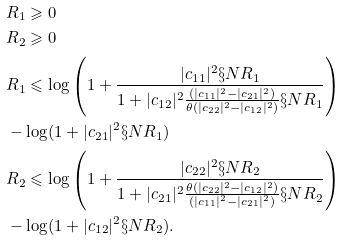Convert formula to latex. <formula><loc_0><loc_0><loc_500><loc_500>& R _ { 1 } \geqslant 0 \\ & R _ { 2 } \geqslant 0 \\ & R _ { 1 } \leqslant \log \left ( 1 + \frac { | c _ { 1 1 } | ^ { 2 } \S N R _ { 1 } } { 1 + | c _ { 1 2 } | ^ { 2 } \frac { ( | c _ { 1 1 } | ^ { 2 } - | c _ { 2 1 } | ^ { 2 } ) } { \theta ( | c _ { 2 2 } | ^ { 2 } - | c _ { 1 2 } | ^ { 2 } ) } \S N R _ { 1 } } \right ) \\ & - \log ( 1 + | c _ { 2 1 } | ^ { 2 } \S N R _ { 1 } ) \\ & R _ { 2 } \leqslant \log \left ( 1 + \frac { | c _ { 2 2 } | ^ { 2 } \S N R _ { 2 } } { 1 + | c _ { 2 1 } | ^ { 2 } \frac { \theta ( | c _ { 2 2 } | ^ { 2 } - | c _ { 1 2 } | ^ { 2 } ) } { ( | c _ { 1 1 } | ^ { 2 } - | c _ { 2 1 } | ^ { 2 } ) } \S N R _ { 2 } } \right ) \\ & - \log ( 1 + | c _ { 1 2 } | ^ { 2 } \S N R _ { 2 } ) .</formula> 